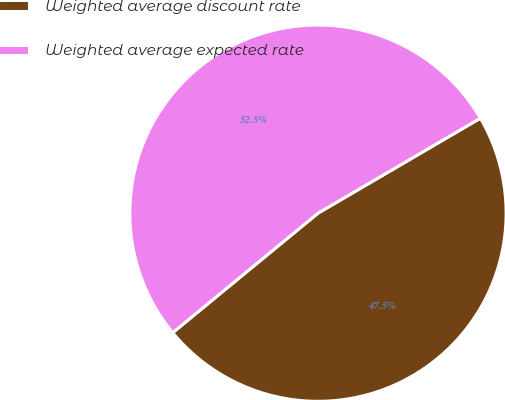Convert chart to OTSL. <chart><loc_0><loc_0><loc_500><loc_500><pie_chart><fcel>Weighted average discount rate<fcel>Weighted average expected rate<nl><fcel>47.47%<fcel>52.53%<nl></chart> 